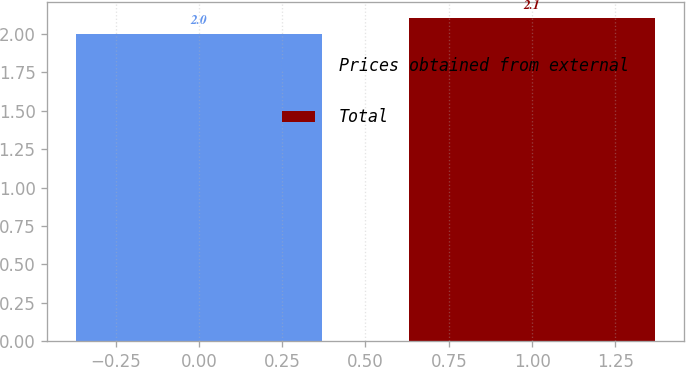Convert chart. <chart><loc_0><loc_0><loc_500><loc_500><bar_chart><fcel>Prices obtained from external<fcel>Total<nl><fcel>2<fcel>2.1<nl></chart> 